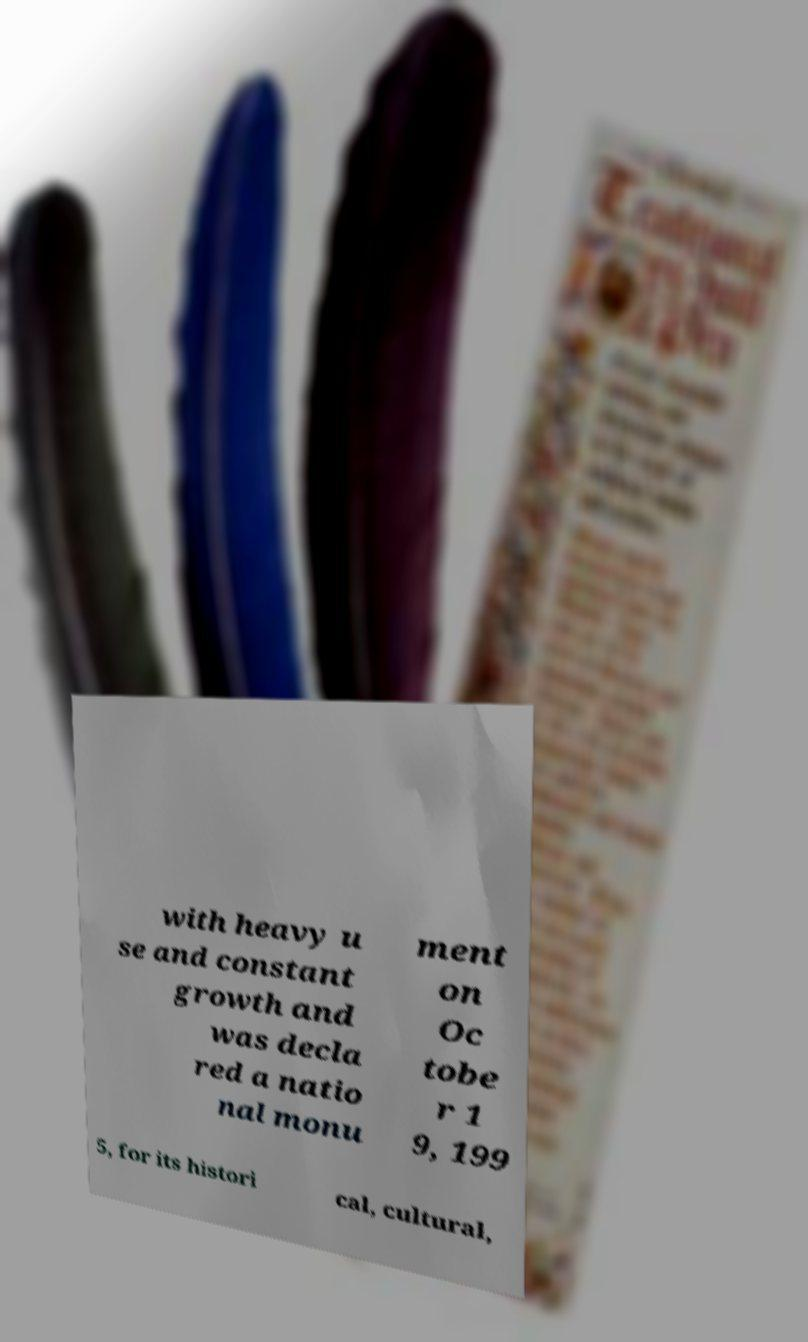Can you read and provide the text displayed in the image?This photo seems to have some interesting text. Can you extract and type it out for me? with heavy u se and constant growth and was decla red a natio nal monu ment on Oc tobe r 1 9, 199 5, for its histori cal, cultural, 